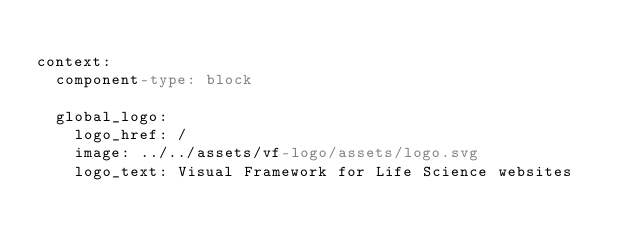<code> <loc_0><loc_0><loc_500><loc_500><_YAML_>
context:
  component-type: block

  global_logo:
    logo_href: /
    image: ../../assets/vf-logo/assets/logo.svg
    logo_text: Visual Framework for Life Science websites
</code> 